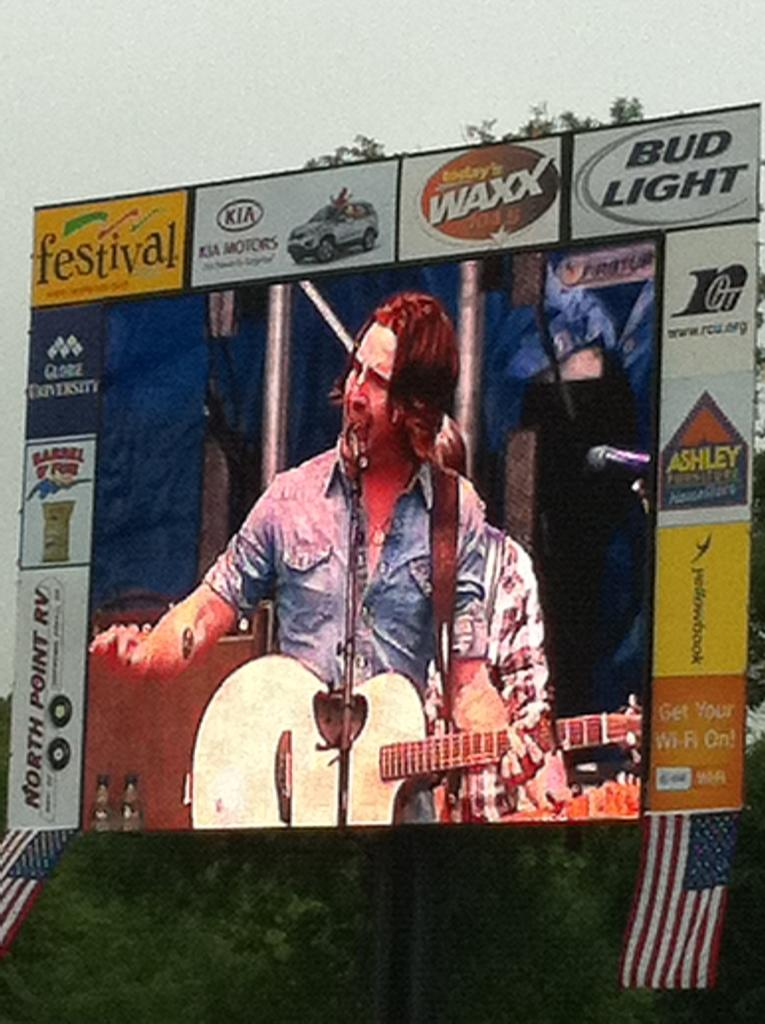What is the main feature of the image? There is a big banner in the image. What is attached to the banner? Two flags are attached to the banner. What can be seen at the bottom of the image? There is a pole and greenery present at the bottom of the image. What is visible at the top of the image? The sky is visible at the top of the image. What type of apparel is being worn by the flags in the image? Flags do not wear apparel; they are inanimate objects. What shape is the banner in the image? The shape of the banner is not mentioned in the provided facts, so we cannot determine its shape from the image. 